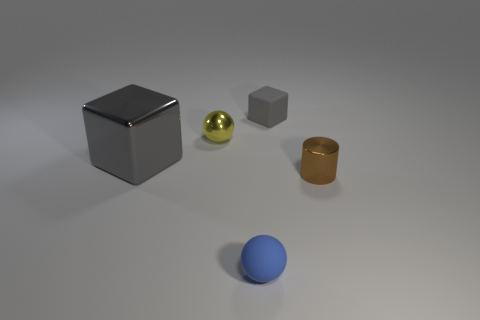How many things are tiny cyan metal cubes or things that are left of the small blue sphere?
Offer a terse response. 2. What is the small sphere that is behind the blue rubber object right of the tiny ball to the left of the tiny blue matte object made of?
Offer a very short reply. Metal. What is the size of the brown cylinder that is the same material as the large block?
Keep it short and to the point. Small. The block to the right of the matte object in front of the gray shiny cube is what color?
Your answer should be compact. Gray. How many other small blocks have the same material as the tiny gray cube?
Ensure brevity in your answer.  0. How many rubber objects are either small yellow objects or small cyan cylinders?
Ensure brevity in your answer.  0. There is a brown cylinder that is the same size as the yellow metallic thing; what is its material?
Make the answer very short. Metal. Is there a brown thing that has the same material as the tiny blue thing?
Offer a very short reply. No. The tiny rubber object that is right of the tiny matte thing that is to the left of the small matte object that is behind the small blue rubber ball is what shape?
Give a very brief answer. Cube. There is a shiny cylinder; is it the same size as the gray block that is left of the blue matte thing?
Offer a very short reply. No. 